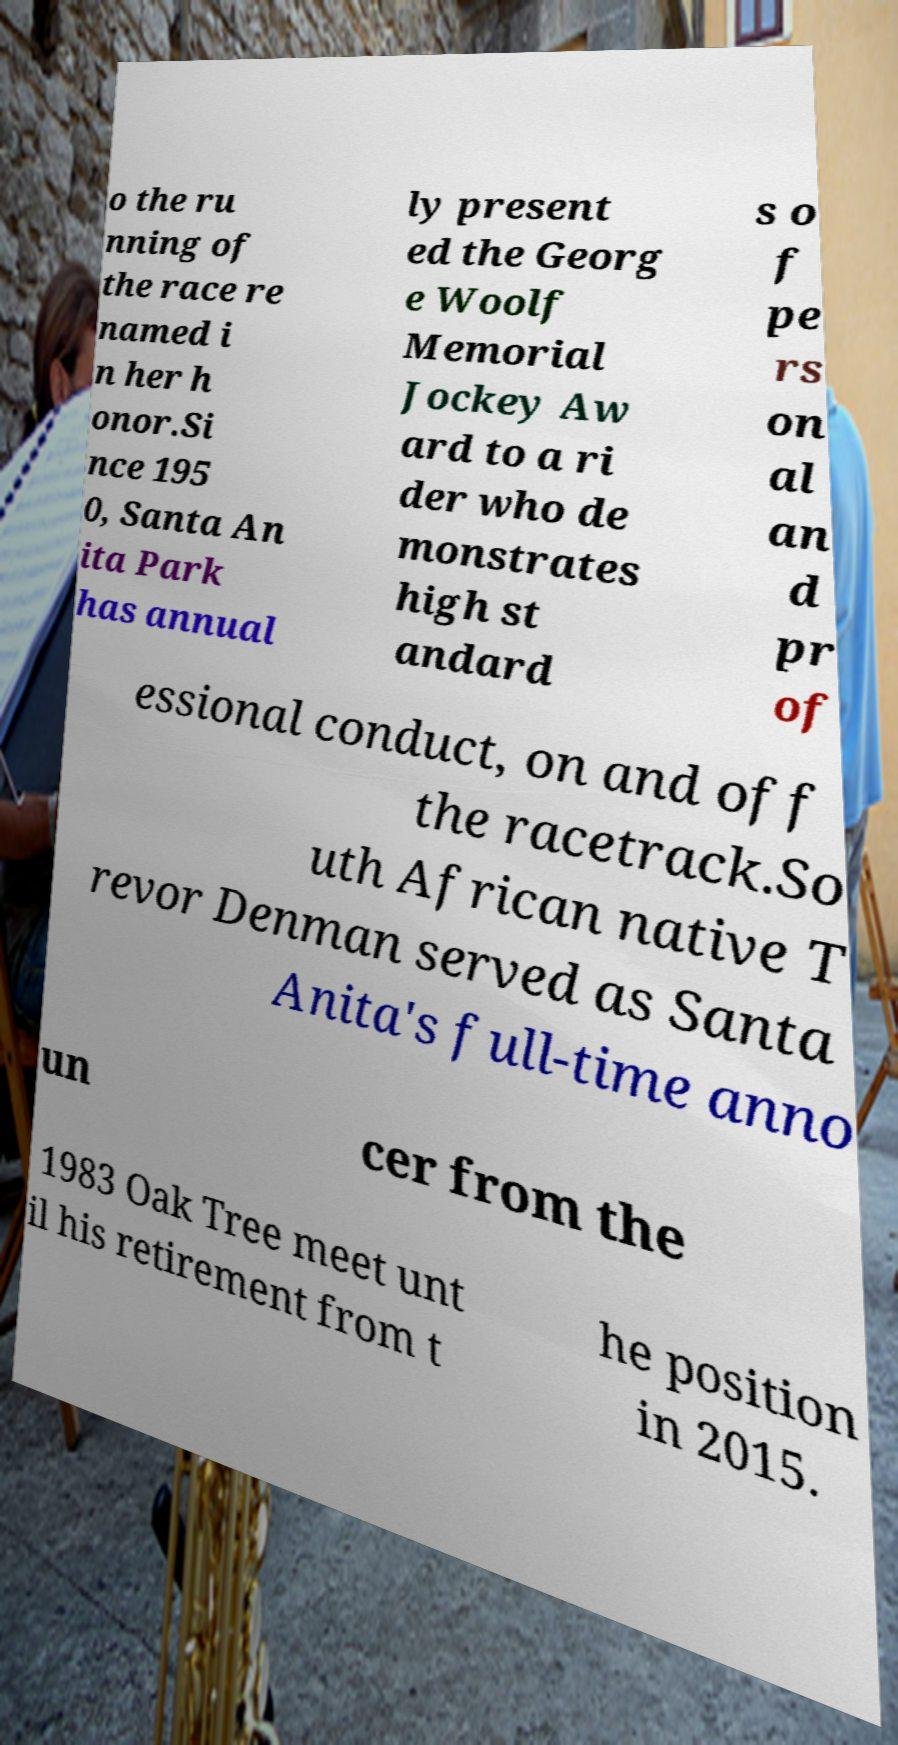What messages or text are displayed in this image? I need them in a readable, typed format. o the ru nning of the race re named i n her h onor.Si nce 195 0, Santa An ita Park has annual ly present ed the Georg e Woolf Memorial Jockey Aw ard to a ri der who de monstrates high st andard s o f pe rs on al an d pr of essional conduct, on and off the racetrack.So uth African native T revor Denman served as Santa Anita's full-time anno un cer from the 1983 Oak Tree meet unt il his retirement from t he position in 2015. 